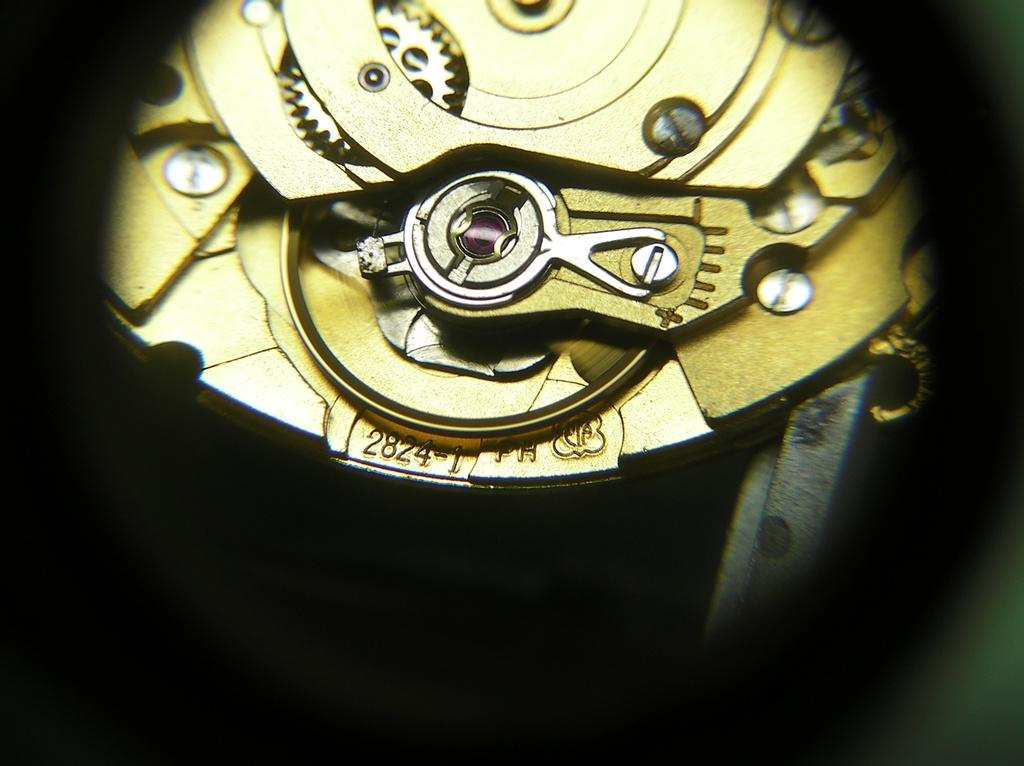<image>
Summarize the visual content of the image. The numbers 2824 etched in the gears of a watch 